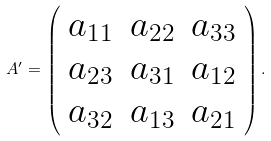<formula> <loc_0><loc_0><loc_500><loc_500>A ^ { \prime } = \left ( \begin{array} { c c c } a _ { 1 1 } & a _ { 2 2 } & a _ { 3 3 } \\ a _ { 2 3 } & a _ { 3 1 } & a _ { 1 2 } \\ a _ { 3 2 } & a _ { 1 3 } & a _ { 2 1 } \end{array} \right ) .</formula> 